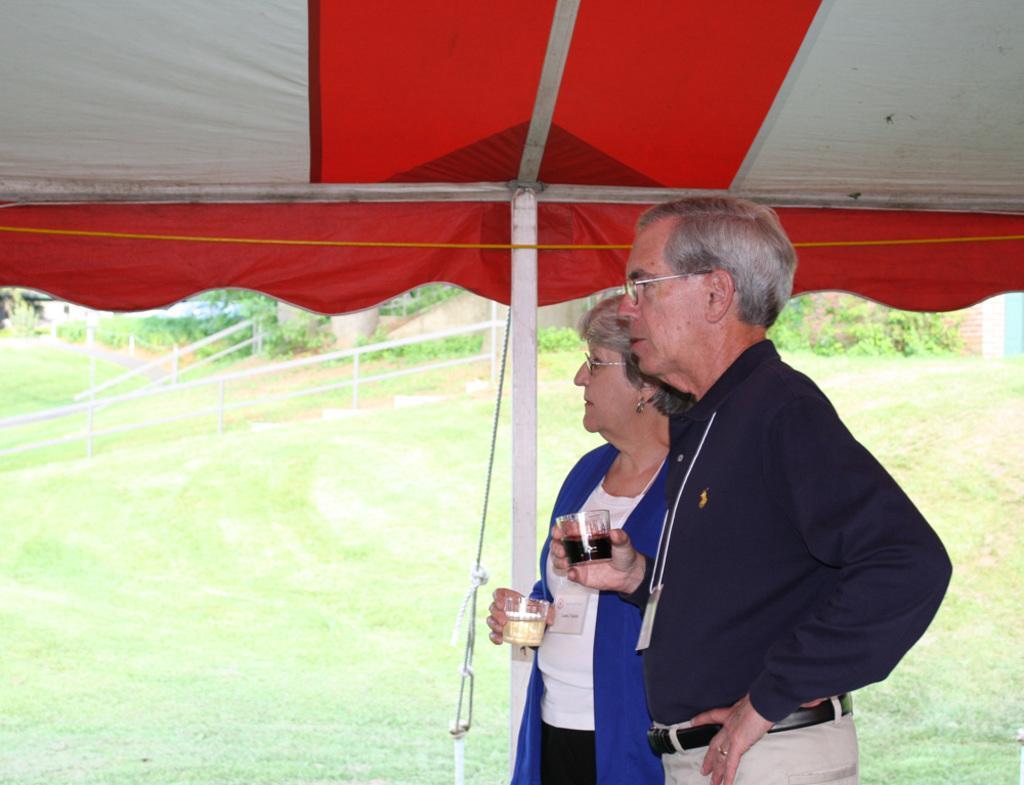Describe this image in one or two sentences. In this image I can see a person wearing black shirt and cream pant and a woman wearing blue jacket are standing and holding glasses in their hands. I can see a tent and white colored pole. In the background I can see some grass, the white railing and few trees. 